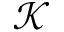Convert formula to latex. <formula><loc_0><loc_0><loc_500><loc_500>\mathcal { K }</formula> 